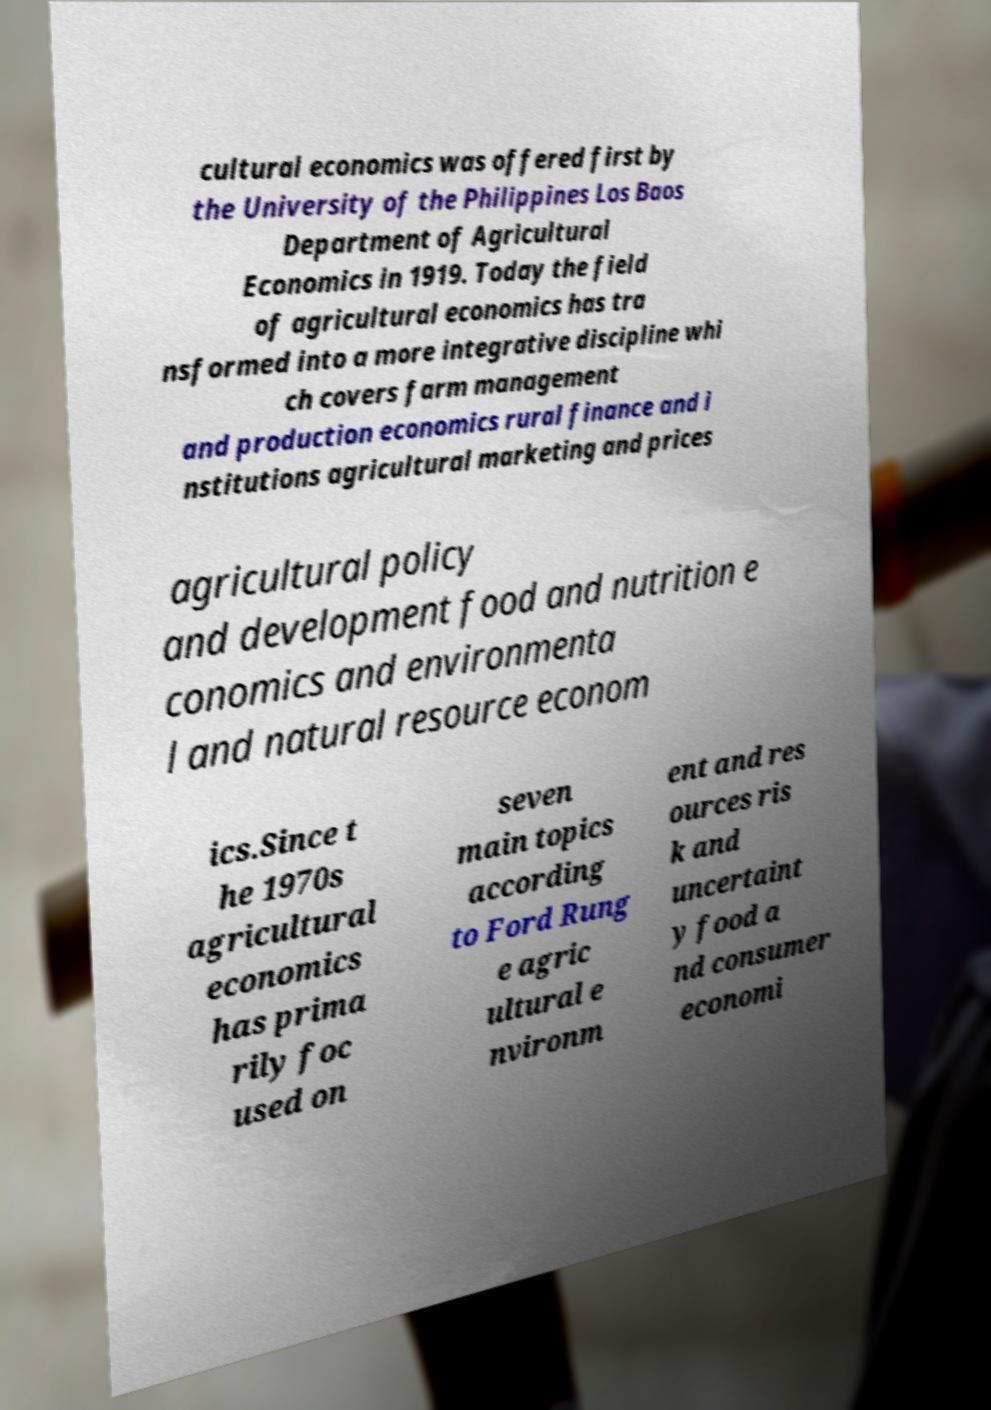What messages or text are displayed in this image? I need them in a readable, typed format. cultural economics was offered first by the University of the Philippines Los Baos Department of Agricultural Economics in 1919. Today the field of agricultural economics has tra nsformed into a more integrative discipline whi ch covers farm management and production economics rural finance and i nstitutions agricultural marketing and prices agricultural policy and development food and nutrition e conomics and environmenta l and natural resource econom ics.Since t he 1970s agricultural economics has prima rily foc used on seven main topics according to Ford Rung e agric ultural e nvironm ent and res ources ris k and uncertaint y food a nd consumer economi 